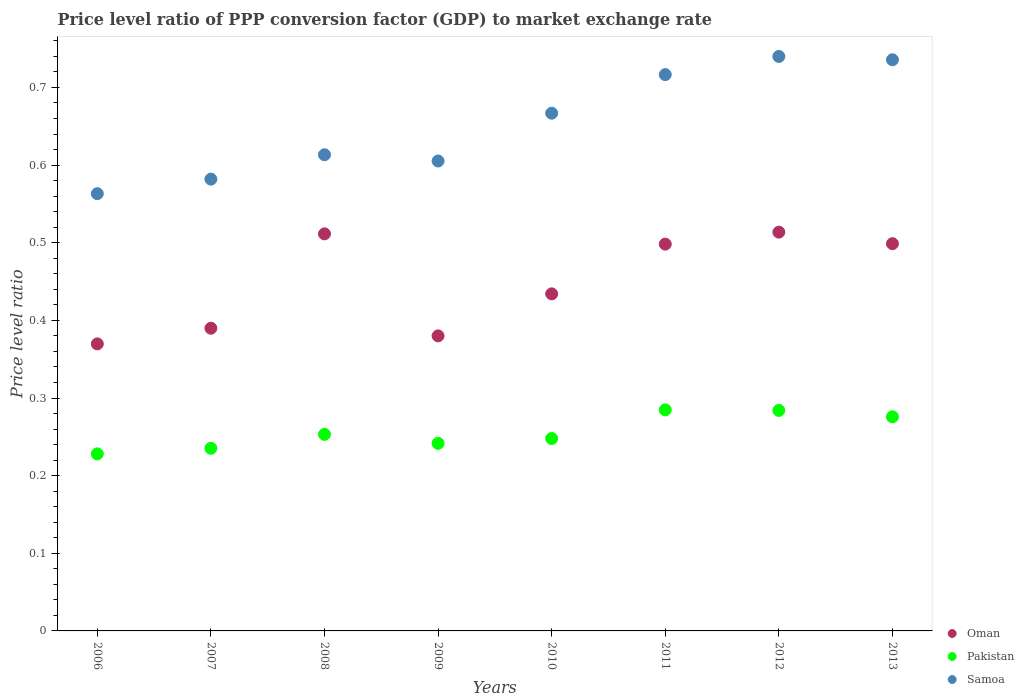What is the price level ratio in Oman in 2012?
Offer a terse response. 0.51. Across all years, what is the maximum price level ratio in Samoa?
Your response must be concise. 0.74. Across all years, what is the minimum price level ratio in Oman?
Your answer should be very brief. 0.37. In which year was the price level ratio in Oman maximum?
Provide a succinct answer. 2012. What is the total price level ratio in Oman in the graph?
Provide a succinct answer. 3.6. What is the difference between the price level ratio in Samoa in 2009 and that in 2012?
Offer a terse response. -0.13. What is the difference between the price level ratio in Samoa in 2009 and the price level ratio in Oman in 2008?
Ensure brevity in your answer.  0.09. What is the average price level ratio in Samoa per year?
Ensure brevity in your answer.  0.65. In the year 2011, what is the difference between the price level ratio in Samoa and price level ratio in Pakistan?
Your response must be concise. 0.43. In how many years, is the price level ratio in Samoa greater than 0.7400000000000001?
Give a very brief answer. 0. What is the ratio of the price level ratio in Samoa in 2010 to that in 2011?
Make the answer very short. 0.93. Is the price level ratio in Samoa in 2011 less than that in 2012?
Your answer should be compact. Yes. Is the difference between the price level ratio in Samoa in 2008 and 2010 greater than the difference between the price level ratio in Pakistan in 2008 and 2010?
Your response must be concise. No. What is the difference between the highest and the second highest price level ratio in Samoa?
Your answer should be compact. 0. What is the difference between the highest and the lowest price level ratio in Samoa?
Your answer should be compact. 0.18. In how many years, is the price level ratio in Pakistan greater than the average price level ratio in Pakistan taken over all years?
Give a very brief answer. 3. Is the sum of the price level ratio in Pakistan in 2009 and 2010 greater than the maximum price level ratio in Samoa across all years?
Ensure brevity in your answer.  No. Is it the case that in every year, the sum of the price level ratio in Oman and price level ratio in Pakistan  is greater than the price level ratio in Samoa?
Make the answer very short. Yes. Is the price level ratio in Samoa strictly greater than the price level ratio in Pakistan over the years?
Make the answer very short. Yes. Is the price level ratio in Samoa strictly less than the price level ratio in Oman over the years?
Give a very brief answer. No. How many dotlines are there?
Your answer should be compact. 3. What is the difference between two consecutive major ticks on the Y-axis?
Your answer should be compact. 0.1. Does the graph contain any zero values?
Provide a succinct answer. No. Does the graph contain grids?
Your response must be concise. No. Where does the legend appear in the graph?
Your response must be concise. Bottom right. What is the title of the graph?
Make the answer very short. Price level ratio of PPP conversion factor (GDP) to market exchange rate. What is the label or title of the X-axis?
Offer a terse response. Years. What is the label or title of the Y-axis?
Keep it short and to the point. Price level ratio. What is the Price level ratio of Oman in 2006?
Your response must be concise. 0.37. What is the Price level ratio of Pakistan in 2006?
Keep it short and to the point. 0.23. What is the Price level ratio in Samoa in 2006?
Make the answer very short. 0.56. What is the Price level ratio of Oman in 2007?
Offer a terse response. 0.39. What is the Price level ratio of Pakistan in 2007?
Give a very brief answer. 0.24. What is the Price level ratio of Samoa in 2007?
Offer a terse response. 0.58. What is the Price level ratio of Oman in 2008?
Offer a very short reply. 0.51. What is the Price level ratio of Pakistan in 2008?
Offer a terse response. 0.25. What is the Price level ratio in Samoa in 2008?
Offer a terse response. 0.61. What is the Price level ratio in Oman in 2009?
Keep it short and to the point. 0.38. What is the Price level ratio in Pakistan in 2009?
Your answer should be very brief. 0.24. What is the Price level ratio of Samoa in 2009?
Offer a terse response. 0.61. What is the Price level ratio of Oman in 2010?
Your response must be concise. 0.43. What is the Price level ratio in Pakistan in 2010?
Provide a short and direct response. 0.25. What is the Price level ratio of Samoa in 2010?
Your response must be concise. 0.67. What is the Price level ratio in Oman in 2011?
Your response must be concise. 0.5. What is the Price level ratio of Pakistan in 2011?
Your response must be concise. 0.28. What is the Price level ratio in Samoa in 2011?
Offer a very short reply. 0.72. What is the Price level ratio of Oman in 2012?
Keep it short and to the point. 0.51. What is the Price level ratio of Pakistan in 2012?
Your answer should be very brief. 0.28. What is the Price level ratio of Samoa in 2012?
Give a very brief answer. 0.74. What is the Price level ratio of Oman in 2013?
Offer a very short reply. 0.5. What is the Price level ratio of Pakistan in 2013?
Provide a short and direct response. 0.28. What is the Price level ratio of Samoa in 2013?
Your answer should be compact. 0.74. Across all years, what is the maximum Price level ratio of Oman?
Provide a succinct answer. 0.51. Across all years, what is the maximum Price level ratio in Pakistan?
Provide a short and direct response. 0.28. Across all years, what is the maximum Price level ratio of Samoa?
Offer a terse response. 0.74. Across all years, what is the minimum Price level ratio of Oman?
Provide a short and direct response. 0.37. Across all years, what is the minimum Price level ratio in Pakistan?
Give a very brief answer. 0.23. Across all years, what is the minimum Price level ratio of Samoa?
Make the answer very short. 0.56. What is the total Price level ratio of Oman in the graph?
Offer a terse response. 3.6. What is the total Price level ratio in Pakistan in the graph?
Provide a short and direct response. 2.05. What is the total Price level ratio of Samoa in the graph?
Your answer should be very brief. 5.22. What is the difference between the Price level ratio of Oman in 2006 and that in 2007?
Offer a terse response. -0.02. What is the difference between the Price level ratio of Pakistan in 2006 and that in 2007?
Your response must be concise. -0.01. What is the difference between the Price level ratio in Samoa in 2006 and that in 2007?
Your answer should be very brief. -0.02. What is the difference between the Price level ratio in Oman in 2006 and that in 2008?
Your response must be concise. -0.14. What is the difference between the Price level ratio of Pakistan in 2006 and that in 2008?
Offer a terse response. -0.03. What is the difference between the Price level ratio in Samoa in 2006 and that in 2008?
Offer a very short reply. -0.05. What is the difference between the Price level ratio of Oman in 2006 and that in 2009?
Keep it short and to the point. -0.01. What is the difference between the Price level ratio of Pakistan in 2006 and that in 2009?
Your answer should be very brief. -0.01. What is the difference between the Price level ratio in Samoa in 2006 and that in 2009?
Provide a short and direct response. -0.04. What is the difference between the Price level ratio of Oman in 2006 and that in 2010?
Your response must be concise. -0.06. What is the difference between the Price level ratio of Pakistan in 2006 and that in 2010?
Provide a succinct answer. -0.02. What is the difference between the Price level ratio in Samoa in 2006 and that in 2010?
Offer a terse response. -0.1. What is the difference between the Price level ratio of Oman in 2006 and that in 2011?
Your answer should be compact. -0.13. What is the difference between the Price level ratio of Pakistan in 2006 and that in 2011?
Give a very brief answer. -0.06. What is the difference between the Price level ratio of Samoa in 2006 and that in 2011?
Provide a succinct answer. -0.15. What is the difference between the Price level ratio in Oman in 2006 and that in 2012?
Make the answer very short. -0.14. What is the difference between the Price level ratio of Pakistan in 2006 and that in 2012?
Keep it short and to the point. -0.06. What is the difference between the Price level ratio of Samoa in 2006 and that in 2012?
Give a very brief answer. -0.18. What is the difference between the Price level ratio in Oman in 2006 and that in 2013?
Your answer should be compact. -0.13. What is the difference between the Price level ratio of Pakistan in 2006 and that in 2013?
Give a very brief answer. -0.05. What is the difference between the Price level ratio of Samoa in 2006 and that in 2013?
Make the answer very short. -0.17. What is the difference between the Price level ratio of Oman in 2007 and that in 2008?
Provide a succinct answer. -0.12. What is the difference between the Price level ratio of Pakistan in 2007 and that in 2008?
Make the answer very short. -0.02. What is the difference between the Price level ratio in Samoa in 2007 and that in 2008?
Your response must be concise. -0.03. What is the difference between the Price level ratio in Oman in 2007 and that in 2009?
Give a very brief answer. 0.01. What is the difference between the Price level ratio in Pakistan in 2007 and that in 2009?
Ensure brevity in your answer.  -0.01. What is the difference between the Price level ratio in Samoa in 2007 and that in 2009?
Your answer should be very brief. -0.02. What is the difference between the Price level ratio in Oman in 2007 and that in 2010?
Give a very brief answer. -0.04. What is the difference between the Price level ratio in Pakistan in 2007 and that in 2010?
Provide a short and direct response. -0.01. What is the difference between the Price level ratio of Samoa in 2007 and that in 2010?
Provide a short and direct response. -0.08. What is the difference between the Price level ratio in Oman in 2007 and that in 2011?
Your response must be concise. -0.11. What is the difference between the Price level ratio in Pakistan in 2007 and that in 2011?
Your answer should be very brief. -0.05. What is the difference between the Price level ratio in Samoa in 2007 and that in 2011?
Ensure brevity in your answer.  -0.13. What is the difference between the Price level ratio of Oman in 2007 and that in 2012?
Give a very brief answer. -0.12. What is the difference between the Price level ratio in Pakistan in 2007 and that in 2012?
Provide a succinct answer. -0.05. What is the difference between the Price level ratio of Samoa in 2007 and that in 2012?
Give a very brief answer. -0.16. What is the difference between the Price level ratio in Oman in 2007 and that in 2013?
Your answer should be very brief. -0.11. What is the difference between the Price level ratio of Pakistan in 2007 and that in 2013?
Your response must be concise. -0.04. What is the difference between the Price level ratio in Samoa in 2007 and that in 2013?
Make the answer very short. -0.15. What is the difference between the Price level ratio in Oman in 2008 and that in 2009?
Give a very brief answer. 0.13. What is the difference between the Price level ratio of Pakistan in 2008 and that in 2009?
Offer a terse response. 0.01. What is the difference between the Price level ratio of Samoa in 2008 and that in 2009?
Your answer should be very brief. 0.01. What is the difference between the Price level ratio in Oman in 2008 and that in 2010?
Your answer should be compact. 0.08. What is the difference between the Price level ratio in Pakistan in 2008 and that in 2010?
Your answer should be very brief. 0.01. What is the difference between the Price level ratio in Samoa in 2008 and that in 2010?
Make the answer very short. -0.05. What is the difference between the Price level ratio of Oman in 2008 and that in 2011?
Provide a succinct answer. 0.01. What is the difference between the Price level ratio in Pakistan in 2008 and that in 2011?
Make the answer very short. -0.03. What is the difference between the Price level ratio in Samoa in 2008 and that in 2011?
Provide a succinct answer. -0.1. What is the difference between the Price level ratio in Oman in 2008 and that in 2012?
Offer a very short reply. -0. What is the difference between the Price level ratio in Pakistan in 2008 and that in 2012?
Your response must be concise. -0.03. What is the difference between the Price level ratio of Samoa in 2008 and that in 2012?
Make the answer very short. -0.13. What is the difference between the Price level ratio of Oman in 2008 and that in 2013?
Keep it short and to the point. 0.01. What is the difference between the Price level ratio in Pakistan in 2008 and that in 2013?
Offer a terse response. -0.02. What is the difference between the Price level ratio of Samoa in 2008 and that in 2013?
Your answer should be very brief. -0.12. What is the difference between the Price level ratio of Oman in 2009 and that in 2010?
Offer a very short reply. -0.05. What is the difference between the Price level ratio in Pakistan in 2009 and that in 2010?
Your answer should be very brief. -0.01. What is the difference between the Price level ratio of Samoa in 2009 and that in 2010?
Your response must be concise. -0.06. What is the difference between the Price level ratio of Oman in 2009 and that in 2011?
Offer a terse response. -0.12. What is the difference between the Price level ratio of Pakistan in 2009 and that in 2011?
Provide a succinct answer. -0.04. What is the difference between the Price level ratio in Samoa in 2009 and that in 2011?
Provide a succinct answer. -0.11. What is the difference between the Price level ratio in Oman in 2009 and that in 2012?
Offer a very short reply. -0.13. What is the difference between the Price level ratio in Pakistan in 2009 and that in 2012?
Ensure brevity in your answer.  -0.04. What is the difference between the Price level ratio in Samoa in 2009 and that in 2012?
Provide a short and direct response. -0.13. What is the difference between the Price level ratio of Oman in 2009 and that in 2013?
Provide a succinct answer. -0.12. What is the difference between the Price level ratio in Pakistan in 2009 and that in 2013?
Make the answer very short. -0.03. What is the difference between the Price level ratio in Samoa in 2009 and that in 2013?
Provide a short and direct response. -0.13. What is the difference between the Price level ratio in Oman in 2010 and that in 2011?
Make the answer very short. -0.06. What is the difference between the Price level ratio of Pakistan in 2010 and that in 2011?
Your answer should be very brief. -0.04. What is the difference between the Price level ratio of Samoa in 2010 and that in 2011?
Provide a short and direct response. -0.05. What is the difference between the Price level ratio in Oman in 2010 and that in 2012?
Offer a terse response. -0.08. What is the difference between the Price level ratio of Pakistan in 2010 and that in 2012?
Offer a very short reply. -0.04. What is the difference between the Price level ratio in Samoa in 2010 and that in 2012?
Provide a short and direct response. -0.07. What is the difference between the Price level ratio in Oman in 2010 and that in 2013?
Your answer should be compact. -0.06. What is the difference between the Price level ratio in Pakistan in 2010 and that in 2013?
Your response must be concise. -0.03. What is the difference between the Price level ratio in Samoa in 2010 and that in 2013?
Your answer should be compact. -0.07. What is the difference between the Price level ratio in Oman in 2011 and that in 2012?
Offer a very short reply. -0.02. What is the difference between the Price level ratio of Pakistan in 2011 and that in 2012?
Your answer should be very brief. 0. What is the difference between the Price level ratio in Samoa in 2011 and that in 2012?
Provide a succinct answer. -0.02. What is the difference between the Price level ratio in Oman in 2011 and that in 2013?
Provide a succinct answer. -0. What is the difference between the Price level ratio of Pakistan in 2011 and that in 2013?
Ensure brevity in your answer.  0.01. What is the difference between the Price level ratio of Samoa in 2011 and that in 2013?
Ensure brevity in your answer.  -0.02. What is the difference between the Price level ratio of Oman in 2012 and that in 2013?
Keep it short and to the point. 0.01. What is the difference between the Price level ratio of Pakistan in 2012 and that in 2013?
Provide a short and direct response. 0.01. What is the difference between the Price level ratio in Samoa in 2012 and that in 2013?
Your answer should be compact. 0. What is the difference between the Price level ratio of Oman in 2006 and the Price level ratio of Pakistan in 2007?
Provide a succinct answer. 0.13. What is the difference between the Price level ratio of Oman in 2006 and the Price level ratio of Samoa in 2007?
Give a very brief answer. -0.21. What is the difference between the Price level ratio of Pakistan in 2006 and the Price level ratio of Samoa in 2007?
Your answer should be compact. -0.35. What is the difference between the Price level ratio of Oman in 2006 and the Price level ratio of Pakistan in 2008?
Offer a terse response. 0.12. What is the difference between the Price level ratio in Oman in 2006 and the Price level ratio in Samoa in 2008?
Make the answer very short. -0.24. What is the difference between the Price level ratio in Pakistan in 2006 and the Price level ratio in Samoa in 2008?
Keep it short and to the point. -0.39. What is the difference between the Price level ratio of Oman in 2006 and the Price level ratio of Pakistan in 2009?
Provide a succinct answer. 0.13. What is the difference between the Price level ratio in Oman in 2006 and the Price level ratio in Samoa in 2009?
Your answer should be very brief. -0.24. What is the difference between the Price level ratio in Pakistan in 2006 and the Price level ratio in Samoa in 2009?
Offer a terse response. -0.38. What is the difference between the Price level ratio of Oman in 2006 and the Price level ratio of Pakistan in 2010?
Provide a succinct answer. 0.12. What is the difference between the Price level ratio of Oman in 2006 and the Price level ratio of Samoa in 2010?
Provide a short and direct response. -0.3. What is the difference between the Price level ratio in Pakistan in 2006 and the Price level ratio in Samoa in 2010?
Your answer should be compact. -0.44. What is the difference between the Price level ratio of Oman in 2006 and the Price level ratio of Pakistan in 2011?
Your answer should be very brief. 0.09. What is the difference between the Price level ratio in Oman in 2006 and the Price level ratio in Samoa in 2011?
Ensure brevity in your answer.  -0.35. What is the difference between the Price level ratio in Pakistan in 2006 and the Price level ratio in Samoa in 2011?
Give a very brief answer. -0.49. What is the difference between the Price level ratio in Oman in 2006 and the Price level ratio in Pakistan in 2012?
Ensure brevity in your answer.  0.09. What is the difference between the Price level ratio in Oman in 2006 and the Price level ratio in Samoa in 2012?
Make the answer very short. -0.37. What is the difference between the Price level ratio of Pakistan in 2006 and the Price level ratio of Samoa in 2012?
Your answer should be compact. -0.51. What is the difference between the Price level ratio in Oman in 2006 and the Price level ratio in Pakistan in 2013?
Offer a terse response. 0.09. What is the difference between the Price level ratio in Oman in 2006 and the Price level ratio in Samoa in 2013?
Offer a terse response. -0.37. What is the difference between the Price level ratio in Pakistan in 2006 and the Price level ratio in Samoa in 2013?
Your answer should be very brief. -0.51. What is the difference between the Price level ratio in Oman in 2007 and the Price level ratio in Pakistan in 2008?
Give a very brief answer. 0.14. What is the difference between the Price level ratio of Oman in 2007 and the Price level ratio of Samoa in 2008?
Provide a short and direct response. -0.22. What is the difference between the Price level ratio of Pakistan in 2007 and the Price level ratio of Samoa in 2008?
Your response must be concise. -0.38. What is the difference between the Price level ratio of Oman in 2007 and the Price level ratio of Pakistan in 2009?
Make the answer very short. 0.15. What is the difference between the Price level ratio of Oman in 2007 and the Price level ratio of Samoa in 2009?
Make the answer very short. -0.22. What is the difference between the Price level ratio in Pakistan in 2007 and the Price level ratio in Samoa in 2009?
Make the answer very short. -0.37. What is the difference between the Price level ratio of Oman in 2007 and the Price level ratio of Pakistan in 2010?
Provide a short and direct response. 0.14. What is the difference between the Price level ratio of Oman in 2007 and the Price level ratio of Samoa in 2010?
Provide a short and direct response. -0.28. What is the difference between the Price level ratio in Pakistan in 2007 and the Price level ratio in Samoa in 2010?
Your answer should be compact. -0.43. What is the difference between the Price level ratio in Oman in 2007 and the Price level ratio in Pakistan in 2011?
Ensure brevity in your answer.  0.11. What is the difference between the Price level ratio in Oman in 2007 and the Price level ratio in Samoa in 2011?
Offer a terse response. -0.33. What is the difference between the Price level ratio in Pakistan in 2007 and the Price level ratio in Samoa in 2011?
Your answer should be compact. -0.48. What is the difference between the Price level ratio of Oman in 2007 and the Price level ratio of Pakistan in 2012?
Keep it short and to the point. 0.11. What is the difference between the Price level ratio of Oman in 2007 and the Price level ratio of Samoa in 2012?
Provide a short and direct response. -0.35. What is the difference between the Price level ratio of Pakistan in 2007 and the Price level ratio of Samoa in 2012?
Keep it short and to the point. -0.5. What is the difference between the Price level ratio of Oman in 2007 and the Price level ratio of Pakistan in 2013?
Give a very brief answer. 0.11. What is the difference between the Price level ratio of Oman in 2007 and the Price level ratio of Samoa in 2013?
Offer a very short reply. -0.35. What is the difference between the Price level ratio in Pakistan in 2007 and the Price level ratio in Samoa in 2013?
Ensure brevity in your answer.  -0.5. What is the difference between the Price level ratio in Oman in 2008 and the Price level ratio in Pakistan in 2009?
Ensure brevity in your answer.  0.27. What is the difference between the Price level ratio in Oman in 2008 and the Price level ratio in Samoa in 2009?
Make the answer very short. -0.09. What is the difference between the Price level ratio in Pakistan in 2008 and the Price level ratio in Samoa in 2009?
Give a very brief answer. -0.35. What is the difference between the Price level ratio in Oman in 2008 and the Price level ratio in Pakistan in 2010?
Provide a short and direct response. 0.26. What is the difference between the Price level ratio in Oman in 2008 and the Price level ratio in Samoa in 2010?
Your response must be concise. -0.16. What is the difference between the Price level ratio in Pakistan in 2008 and the Price level ratio in Samoa in 2010?
Provide a succinct answer. -0.41. What is the difference between the Price level ratio in Oman in 2008 and the Price level ratio in Pakistan in 2011?
Your response must be concise. 0.23. What is the difference between the Price level ratio in Oman in 2008 and the Price level ratio in Samoa in 2011?
Give a very brief answer. -0.21. What is the difference between the Price level ratio in Pakistan in 2008 and the Price level ratio in Samoa in 2011?
Keep it short and to the point. -0.46. What is the difference between the Price level ratio in Oman in 2008 and the Price level ratio in Pakistan in 2012?
Keep it short and to the point. 0.23. What is the difference between the Price level ratio of Oman in 2008 and the Price level ratio of Samoa in 2012?
Your response must be concise. -0.23. What is the difference between the Price level ratio of Pakistan in 2008 and the Price level ratio of Samoa in 2012?
Provide a short and direct response. -0.49. What is the difference between the Price level ratio of Oman in 2008 and the Price level ratio of Pakistan in 2013?
Your answer should be very brief. 0.24. What is the difference between the Price level ratio of Oman in 2008 and the Price level ratio of Samoa in 2013?
Give a very brief answer. -0.22. What is the difference between the Price level ratio of Pakistan in 2008 and the Price level ratio of Samoa in 2013?
Provide a succinct answer. -0.48. What is the difference between the Price level ratio in Oman in 2009 and the Price level ratio in Pakistan in 2010?
Give a very brief answer. 0.13. What is the difference between the Price level ratio of Oman in 2009 and the Price level ratio of Samoa in 2010?
Ensure brevity in your answer.  -0.29. What is the difference between the Price level ratio in Pakistan in 2009 and the Price level ratio in Samoa in 2010?
Keep it short and to the point. -0.43. What is the difference between the Price level ratio of Oman in 2009 and the Price level ratio of Pakistan in 2011?
Make the answer very short. 0.1. What is the difference between the Price level ratio in Oman in 2009 and the Price level ratio in Samoa in 2011?
Keep it short and to the point. -0.34. What is the difference between the Price level ratio of Pakistan in 2009 and the Price level ratio of Samoa in 2011?
Offer a terse response. -0.47. What is the difference between the Price level ratio in Oman in 2009 and the Price level ratio in Pakistan in 2012?
Ensure brevity in your answer.  0.1. What is the difference between the Price level ratio in Oman in 2009 and the Price level ratio in Samoa in 2012?
Provide a short and direct response. -0.36. What is the difference between the Price level ratio in Pakistan in 2009 and the Price level ratio in Samoa in 2012?
Provide a succinct answer. -0.5. What is the difference between the Price level ratio in Oman in 2009 and the Price level ratio in Pakistan in 2013?
Make the answer very short. 0.1. What is the difference between the Price level ratio in Oman in 2009 and the Price level ratio in Samoa in 2013?
Offer a very short reply. -0.36. What is the difference between the Price level ratio in Pakistan in 2009 and the Price level ratio in Samoa in 2013?
Your answer should be compact. -0.49. What is the difference between the Price level ratio of Oman in 2010 and the Price level ratio of Pakistan in 2011?
Offer a very short reply. 0.15. What is the difference between the Price level ratio of Oman in 2010 and the Price level ratio of Samoa in 2011?
Your answer should be compact. -0.28. What is the difference between the Price level ratio of Pakistan in 2010 and the Price level ratio of Samoa in 2011?
Your answer should be compact. -0.47. What is the difference between the Price level ratio in Oman in 2010 and the Price level ratio in Pakistan in 2012?
Make the answer very short. 0.15. What is the difference between the Price level ratio in Oman in 2010 and the Price level ratio in Samoa in 2012?
Provide a succinct answer. -0.31. What is the difference between the Price level ratio in Pakistan in 2010 and the Price level ratio in Samoa in 2012?
Keep it short and to the point. -0.49. What is the difference between the Price level ratio of Oman in 2010 and the Price level ratio of Pakistan in 2013?
Your answer should be compact. 0.16. What is the difference between the Price level ratio in Oman in 2010 and the Price level ratio in Samoa in 2013?
Provide a succinct answer. -0.3. What is the difference between the Price level ratio of Pakistan in 2010 and the Price level ratio of Samoa in 2013?
Your answer should be very brief. -0.49. What is the difference between the Price level ratio in Oman in 2011 and the Price level ratio in Pakistan in 2012?
Make the answer very short. 0.21. What is the difference between the Price level ratio in Oman in 2011 and the Price level ratio in Samoa in 2012?
Keep it short and to the point. -0.24. What is the difference between the Price level ratio in Pakistan in 2011 and the Price level ratio in Samoa in 2012?
Make the answer very short. -0.46. What is the difference between the Price level ratio of Oman in 2011 and the Price level ratio of Pakistan in 2013?
Give a very brief answer. 0.22. What is the difference between the Price level ratio in Oman in 2011 and the Price level ratio in Samoa in 2013?
Ensure brevity in your answer.  -0.24. What is the difference between the Price level ratio in Pakistan in 2011 and the Price level ratio in Samoa in 2013?
Give a very brief answer. -0.45. What is the difference between the Price level ratio of Oman in 2012 and the Price level ratio of Pakistan in 2013?
Provide a short and direct response. 0.24. What is the difference between the Price level ratio of Oman in 2012 and the Price level ratio of Samoa in 2013?
Your response must be concise. -0.22. What is the difference between the Price level ratio of Pakistan in 2012 and the Price level ratio of Samoa in 2013?
Provide a succinct answer. -0.45. What is the average Price level ratio of Oman per year?
Offer a very short reply. 0.45. What is the average Price level ratio in Pakistan per year?
Your response must be concise. 0.26. What is the average Price level ratio in Samoa per year?
Your answer should be compact. 0.65. In the year 2006, what is the difference between the Price level ratio of Oman and Price level ratio of Pakistan?
Offer a terse response. 0.14. In the year 2006, what is the difference between the Price level ratio in Oman and Price level ratio in Samoa?
Provide a short and direct response. -0.19. In the year 2006, what is the difference between the Price level ratio of Pakistan and Price level ratio of Samoa?
Provide a short and direct response. -0.34. In the year 2007, what is the difference between the Price level ratio in Oman and Price level ratio in Pakistan?
Provide a succinct answer. 0.15. In the year 2007, what is the difference between the Price level ratio of Oman and Price level ratio of Samoa?
Your response must be concise. -0.19. In the year 2007, what is the difference between the Price level ratio of Pakistan and Price level ratio of Samoa?
Provide a short and direct response. -0.35. In the year 2008, what is the difference between the Price level ratio of Oman and Price level ratio of Pakistan?
Your answer should be very brief. 0.26. In the year 2008, what is the difference between the Price level ratio of Oman and Price level ratio of Samoa?
Give a very brief answer. -0.1. In the year 2008, what is the difference between the Price level ratio of Pakistan and Price level ratio of Samoa?
Your response must be concise. -0.36. In the year 2009, what is the difference between the Price level ratio of Oman and Price level ratio of Pakistan?
Make the answer very short. 0.14. In the year 2009, what is the difference between the Price level ratio in Oman and Price level ratio in Samoa?
Make the answer very short. -0.23. In the year 2009, what is the difference between the Price level ratio of Pakistan and Price level ratio of Samoa?
Give a very brief answer. -0.36. In the year 2010, what is the difference between the Price level ratio of Oman and Price level ratio of Pakistan?
Ensure brevity in your answer.  0.19. In the year 2010, what is the difference between the Price level ratio of Oman and Price level ratio of Samoa?
Your response must be concise. -0.23. In the year 2010, what is the difference between the Price level ratio in Pakistan and Price level ratio in Samoa?
Provide a short and direct response. -0.42. In the year 2011, what is the difference between the Price level ratio in Oman and Price level ratio in Pakistan?
Provide a short and direct response. 0.21. In the year 2011, what is the difference between the Price level ratio of Oman and Price level ratio of Samoa?
Keep it short and to the point. -0.22. In the year 2011, what is the difference between the Price level ratio in Pakistan and Price level ratio in Samoa?
Provide a short and direct response. -0.43. In the year 2012, what is the difference between the Price level ratio of Oman and Price level ratio of Pakistan?
Your response must be concise. 0.23. In the year 2012, what is the difference between the Price level ratio in Oman and Price level ratio in Samoa?
Offer a very short reply. -0.23. In the year 2012, what is the difference between the Price level ratio of Pakistan and Price level ratio of Samoa?
Ensure brevity in your answer.  -0.46. In the year 2013, what is the difference between the Price level ratio of Oman and Price level ratio of Pakistan?
Make the answer very short. 0.22. In the year 2013, what is the difference between the Price level ratio in Oman and Price level ratio in Samoa?
Offer a very short reply. -0.24. In the year 2013, what is the difference between the Price level ratio in Pakistan and Price level ratio in Samoa?
Provide a succinct answer. -0.46. What is the ratio of the Price level ratio in Oman in 2006 to that in 2007?
Offer a very short reply. 0.95. What is the ratio of the Price level ratio of Pakistan in 2006 to that in 2007?
Give a very brief answer. 0.97. What is the ratio of the Price level ratio in Samoa in 2006 to that in 2007?
Your answer should be very brief. 0.97. What is the ratio of the Price level ratio in Oman in 2006 to that in 2008?
Provide a short and direct response. 0.72. What is the ratio of the Price level ratio of Pakistan in 2006 to that in 2008?
Keep it short and to the point. 0.9. What is the ratio of the Price level ratio of Samoa in 2006 to that in 2008?
Make the answer very short. 0.92. What is the ratio of the Price level ratio in Oman in 2006 to that in 2009?
Offer a very short reply. 0.97. What is the ratio of the Price level ratio in Pakistan in 2006 to that in 2009?
Offer a terse response. 0.94. What is the ratio of the Price level ratio in Samoa in 2006 to that in 2009?
Your answer should be very brief. 0.93. What is the ratio of the Price level ratio of Oman in 2006 to that in 2010?
Offer a terse response. 0.85. What is the ratio of the Price level ratio in Pakistan in 2006 to that in 2010?
Ensure brevity in your answer.  0.92. What is the ratio of the Price level ratio of Samoa in 2006 to that in 2010?
Offer a very short reply. 0.84. What is the ratio of the Price level ratio in Oman in 2006 to that in 2011?
Your response must be concise. 0.74. What is the ratio of the Price level ratio in Pakistan in 2006 to that in 2011?
Your answer should be very brief. 0.8. What is the ratio of the Price level ratio in Samoa in 2006 to that in 2011?
Your answer should be very brief. 0.79. What is the ratio of the Price level ratio of Oman in 2006 to that in 2012?
Offer a terse response. 0.72. What is the ratio of the Price level ratio in Pakistan in 2006 to that in 2012?
Give a very brief answer. 0.8. What is the ratio of the Price level ratio in Samoa in 2006 to that in 2012?
Your answer should be very brief. 0.76. What is the ratio of the Price level ratio in Oman in 2006 to that in 2013?
Offer a very short reply. 0.74. What is the ratio of the Price level ratio in Pakistan in 2006 to that in 2013?
Ensure brevity in your answer.  0.83. What is the ratio of the Price level ratio of Samoa in 2006 to that in 2013?
Your answer should be very brief. 0.77. What is the ratio of the Price level ratio in Oman in 2007 to that in 2008?
Make the answer very short. 0.76. What is the ratio of the Price level ratio in Pakistan in 2007 to that in 2008?
Your response must be concise. 0.93. What is the ratio of the Price level ratio in Samoa in 2007 to that in 2008?
Provide a succinct answer. 0.95. What is the ratio of the Price level ratio of Oman in 2007 to that in 2009?
Provide a succinct answer. 1.03. What is the ratio of the Price level ratio in Pakistan in 2007 to that in 2009?
Keep it short and to the point. 0.97. What is the ratio of the Price level ratio in Samoa in 2007 to that in 2009?
Keep it short and to the point. 0.96. What is the ratio of the Price level ratio of Oman in 2007 to that in 2010?
Your response must be concise. 0.9. What is the ratio of the Price level ratio in Pakistan in 2007 to that in 2010?
Offer a very short reply. 0.95. What is the ratio of the Price level ratio in Samoa in 2007 to that in 2010?
Provide a short and direct response. 0.87. What is the ratio of the Price level ratio in Oman in 2007 to that in 2011?
Give a very brief answer. 0.78. What is the ratio of the Price level ratio in Pakistan in 2007 to that in 2011?
Offer a very short reply. 0.83. What is the ratio of the Price level ratio of Samoa in 2007 to that in 2011?
Offer a very short reply. 0.81. What is the ratio of the Price level ratio in Oman in 2007 to that in 2012?
Offer a very short reply. 0.76. What is the ratio of the Price level ratio of Pakistan in 2007 to that in 2012?
Ensure brevity in your answer.  0.83. What is the ratio of the Price level ratio in Samoa in 2007 to that in 2012?
Make the answer very short. 0.79. What is the ratio of the Price level ratio in Oman in 2007 to that in 2013?
Offer a very short reply. 0.78. What is the ratio of the Price level ratio in Pakistan in 2007 to that in 2013?
Make the answer very short. 0.85. What is the ratio of the Price level ratio in Samoa in 2007 to that in 2013?
Offer a very short reply. 0.79. What is the ratio of the Price level ratio in Oman in 2008 to that in 2009?
Provide a succinct answer. 1.35. What is the ratio of the Price level ratio of Pakistan in 2008 to that in 2009?
Your answer should be very brief. 1.05. What is the ratio of the Price level ratio of Samoa in 2008 to that in 2009?
Offer a terse response. 1.01. What is the ratio of the Price level ratio in Oman in 2008 to that in 2010?
Ensure brevity in your answer.  1.18. What is the ratio of the Price level ratio in Pakistan in 2008 to that in 2010?
Offer a very short reply. 1.02. What is the ratio of the Price level ratio of Samoa in 2008 to that in 2010?
Keep it short and to the point. 0.92. What is the ratio of the Price level ratio in Oman in 2008 to that in 2011?
Your answer should be compact. 1.03. What is the ratio of the Price level ratio in Pakistan in 2008 to that in 2011?
Your response must be concise. 0.89. What is the ratio of the Price level ratio of Samoa in 2008 to that in 2011?
Keep it short and to the point. 0.86. What is the ratio of the Price level ratio of Oman in 2008 to that in 2012?
Make the answer very short. 1. What is the ratio of the Price level ratio in Pakistan in 2008 to that in 2012?
Your answer should be compact. 0.89. What is the ratio of the Price level ratio of Samoa in 2008 to that in 2012?
Offer a very short reply. 0.83. What is the ratio of the Price level ratio in Oman in 2008 to that in 2013?
Your answer should be compact. 1.03. What is the ratio of the Price level ratio of Pakistan in 2008 to that in 2013?
Ensure brevity in your answer.  0.92. What is the ratio of the Price level ratio in Samoa in 2008 to that in 2013?
Your answer should be compact. 0.83. What is the ratio of the Price level ratio in Oman in 2009 to that in 2010?
Keep it short and to the point. 0.88. What is the ratio of the Price level ratio in Pakistan in 2009 to that in 2010?
Keep it short and to the point. 0.97. What is the ratio of the Price level ratio of Samoa in 2009 to that in 2010?
Your answer should be compact. 0.91. What is the ratio of the Price level ratio in Oman in 2009 to that in 2011?
Give a very brief answer. 0.76. What is the ratio of the Price level ratio in Pakistan in 2009 to that in 2011?
Your response must be concise. 0.85. What is the ratio of the Price level ratio of Samoa in 2009 to that in 2011?
Keep it short and to the point. 0.84. What is the ratio of the Price level ratio in Oman in 2009 to that in 2012?
Offer a terse response. 0.74. What is the ratio of the Price level ratio in Pakistan in 2009 to that in 2012?
Give a very brief answer. 0.85. What is the ratio of the Price level ratio in Samoa in 2009 to that in 2012?
Give a very brief answer. 0.82. What is the ratio of the Price level ratio in Oman in 2009 to that in 2013?
Your answer should be very brief. 0.76. What is the ratio of the Price level ratio of Pakistan in 2009 to that in 2013?
Keep it short and to the point. 0.88. What is the ratio of the Price level ratio in Samoa in 2009 to that in 2013?
Offer a very short reply. 0.82. What is the ratio of the Price level ratio of Oman in 2010 to that in 2011?
Offer a terse response. 0.87. What is the ratio of the Price level ratio in Pakistan in 2010 to that in 2011?
Ensure brevity in your answer.  0.87. What is the ratio of the Price level ratio of Samoa in 2010 to that in 2011?
Give a very brief answer. 0.93. What is the ratio of the Price level ratio of Oman in 2010 to that in 2012?
Your answer should be compact. 0.85. What is the ratio of the Price level ratio in Pakistan in 2010 to that in 2012?
Your response must be concise. 0.87. What is the ratio of the Price level ratio in Samoa in 2010 to that in 2012?
Ensure brevity in your answer.  0.9. What is the ratio of the Price level ratio in Oman in 2010 to that in 2013?
Your response must be concise. 0.87. What is the ratio of the Price level ratio of Pakistan in 2010 to that in 2013?
Your response must be concise. 0.9. What is the ratio of the Price level ratio in Samoa in 2010 to that in 2013?
Your response must be concise. 0.91. What is the ratio of the Price level ratio in Oman in 2011 to that in 2012?
Make the answer very short. 0.97. What is the ratio of the Price level ratio in Pakistan in 2011 to that in 2012?
Give a very brief answer. 1. What is the ratio of the Price level ratio of Samoa in 2011 to that in 2012?
Offer a very short reply. 0.97. What is the ratio of the Price level ratio in Pakistan in 2011 to that in 2013?
Give a very brief answer. 1.03. What is the ratio of the Price level ratio in Oman in 2012 to that in 2013?
Provide a short and direct response. 1.03. What is the ratio of the Price level ratio in Pakistan in 2012 to that in 2013?
Your answer should be compact. 1.03. What is the difference between the highest and the second highest Price level ratio in Oman?
Your answer should be very brief. 0. What is the difference between the highest and the second highest Price level ratio of Pakistan?
Your response must be concise. 0. What is the difference between the highest and the second highest Price level ratio in Samoa?
Give a very brief answer. 0. What is the difference between the highest and the lowest Price level ratio of Oman?
Keep it short and to the point. 0.14. What is the difference between the highest and the lowest Price level ratio of Pakistan?
Provide a short and direct response. 0.06. What is the difference between the highest and the lowest Price level ratio in Samoa?
Ensure brevity in your answer.  0.18. 